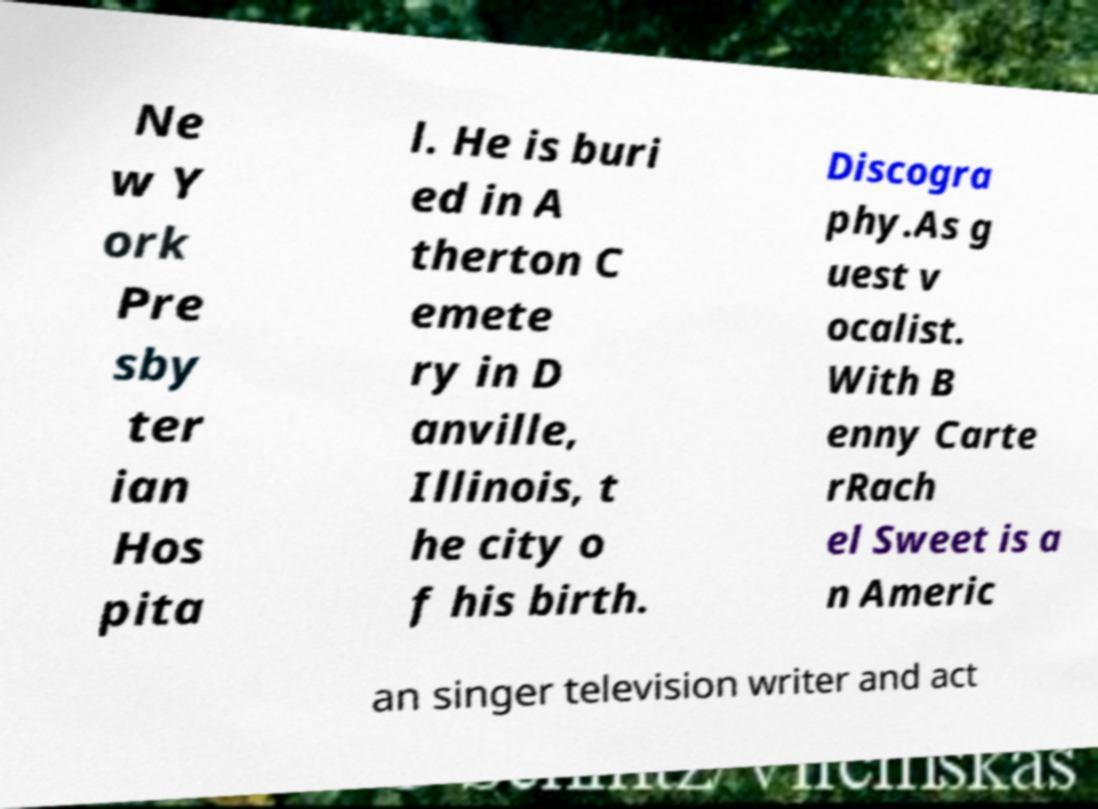What messages or text are displayed in this image? I need them in a readable, typed format. Ne w Y ork Pre sby ter ian Hos pita l. He is buri ed in A therton C emete ry in D anville, Illinois, t he city o f his birth. Discogra phy.As g uest v ocalist. With B enny Carte rRach el Sweet is a n Americ an singer television writer and act 